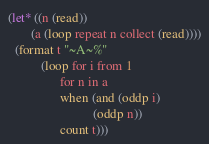<code> <loc_0><loc_0><loc_500><loc_500><_Lisp_>(let* ((n (read))
       (a (loop repeat n collect (read))))
  (format t "~A~%"
          (loop for i from 1
                for n in a
                when (and (oddp i)
                          (oddp n))
                count t)))</code> 